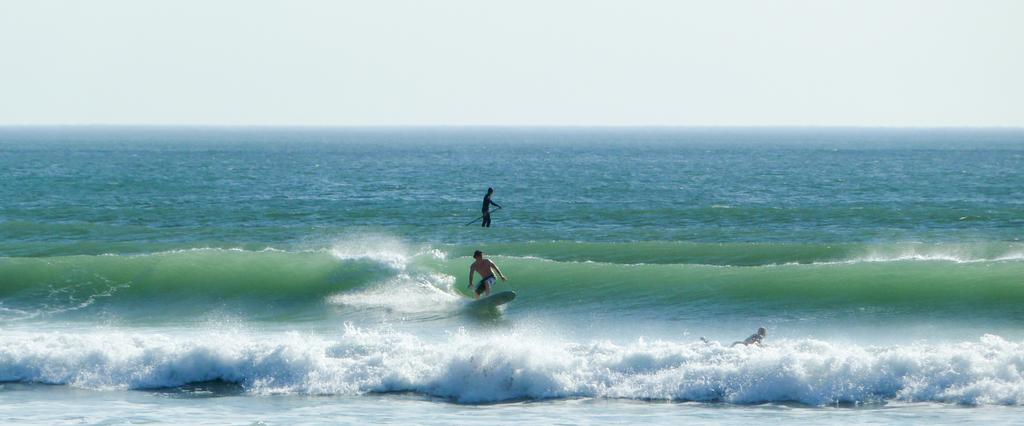Who can be seen in the image? There are people in the image. What are the people doing in the image? The people are surfing. What objects are being used by the people while surfing? Surfboards are visible under the people. What type of environment is the scene taking place in? The scene takes place at a beach. What organization is represented by the window in the image? There is no window present in the image, and therefore no organization can be represented. 